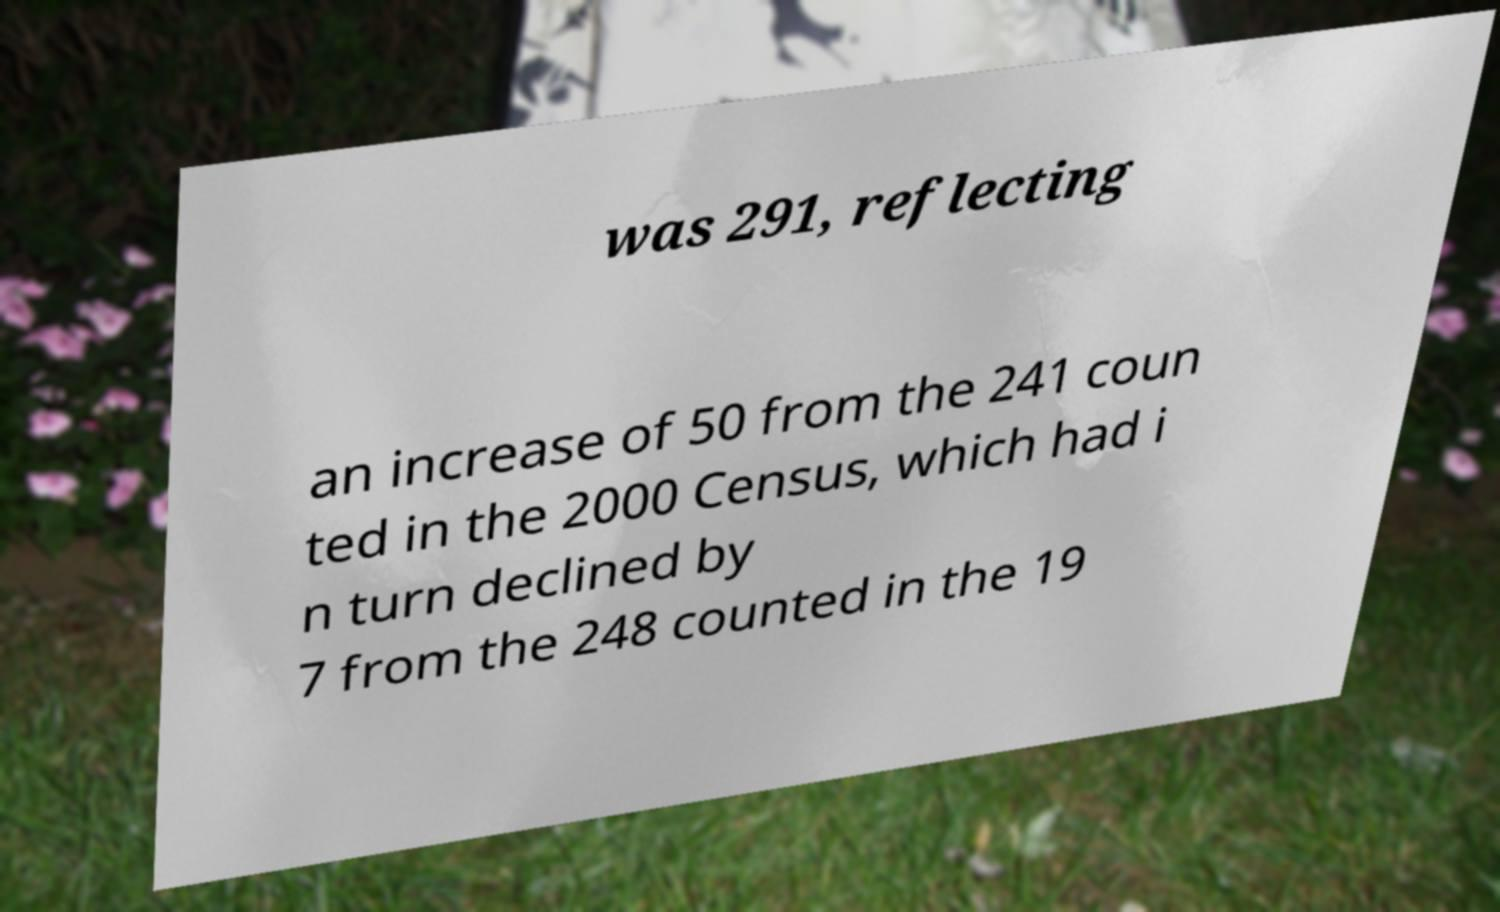Please identify and transcribe the text found in this image. was 291, reflecting an increase of 50 from the 241 coun ted in the 2000 Census, which had i n turn declined by 7 from the 248 counted in the 19 